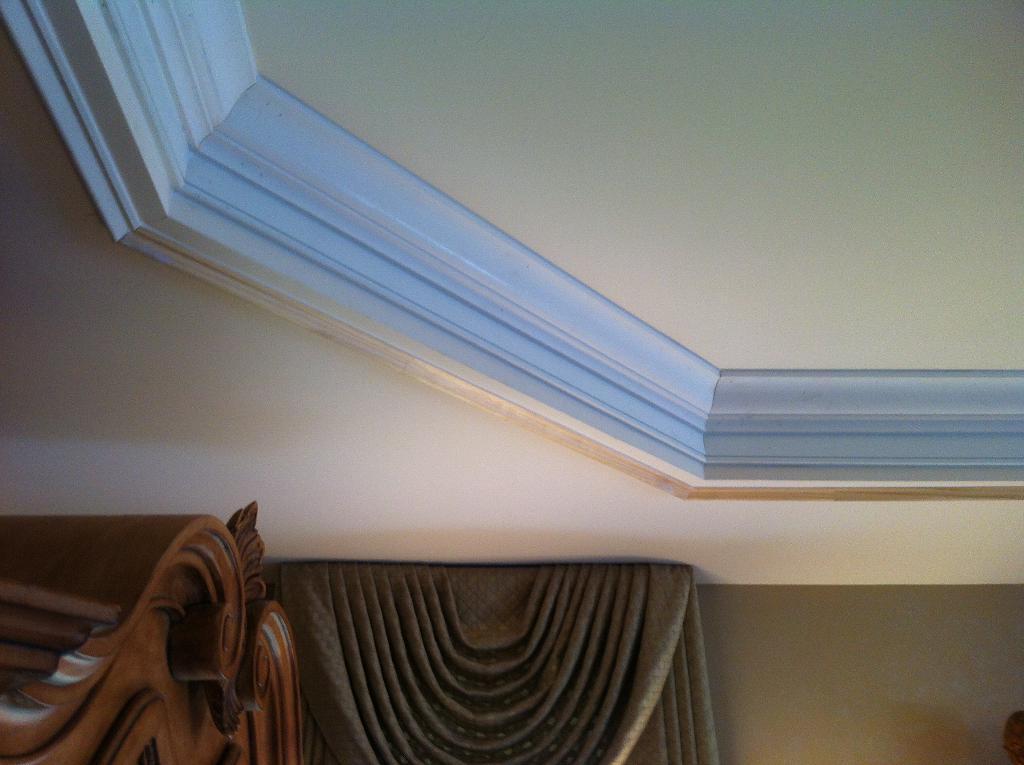Describe this image in one or two sentences. In this image we can see wall, ceiling, curtain, and an object. 